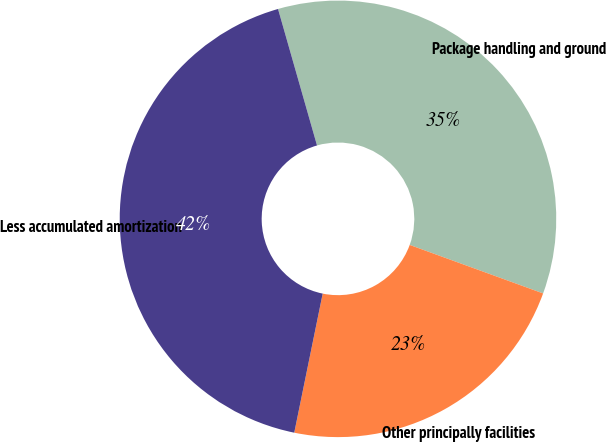Convert chart. <chart><loc_0><loc_0><loc_500><loc_500><pie_chart><fcel>Package handling and ground<fcel>Other principally facilities<fcel>Less accumulated amortization<nl><fcel>34.98%<fcel>22.66%<fcel>42.36%<nl></chart> 